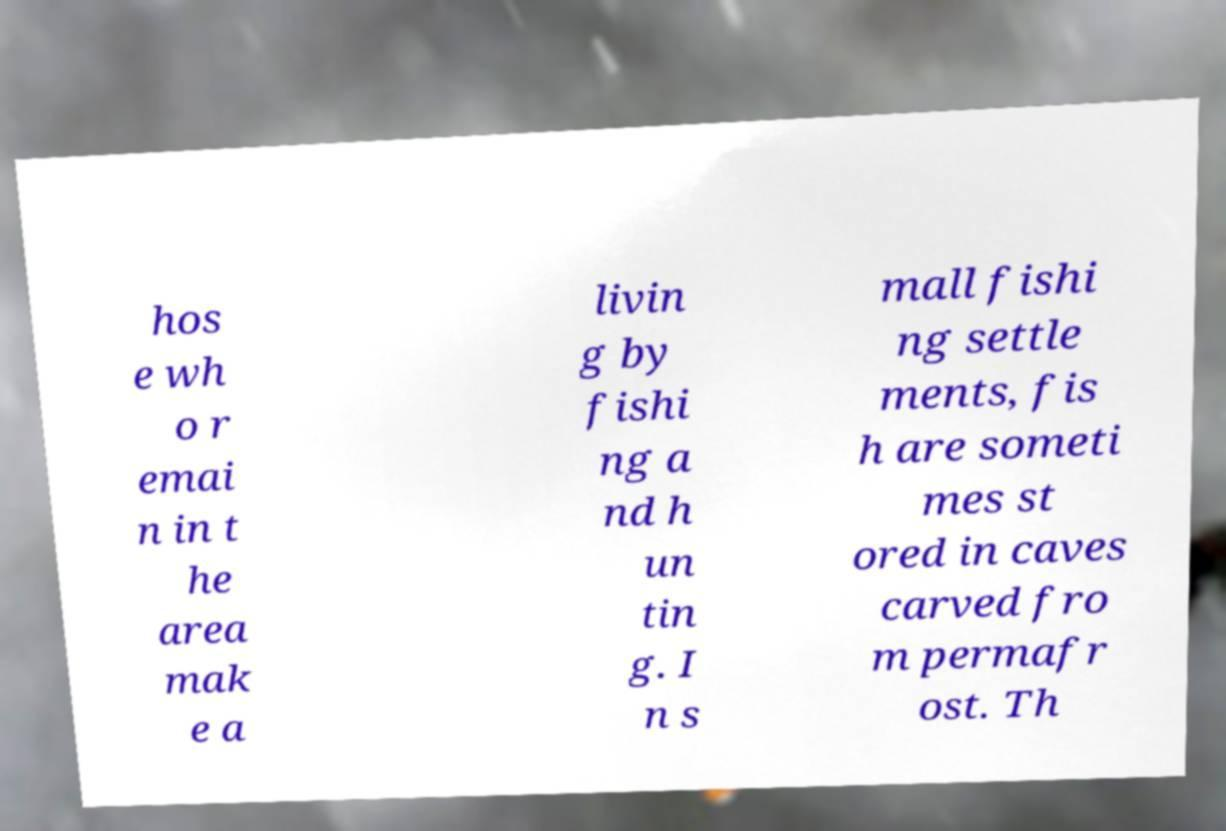Please read and relay the text visible in this image. What does it say? hos e wh o r emai n in t he area mak e a livin g by fishi ng a nd h un tin g. I n s mall fishi ng settle ments, fis h are someti mes st ored in caves carved fro m permafr ost. Th 